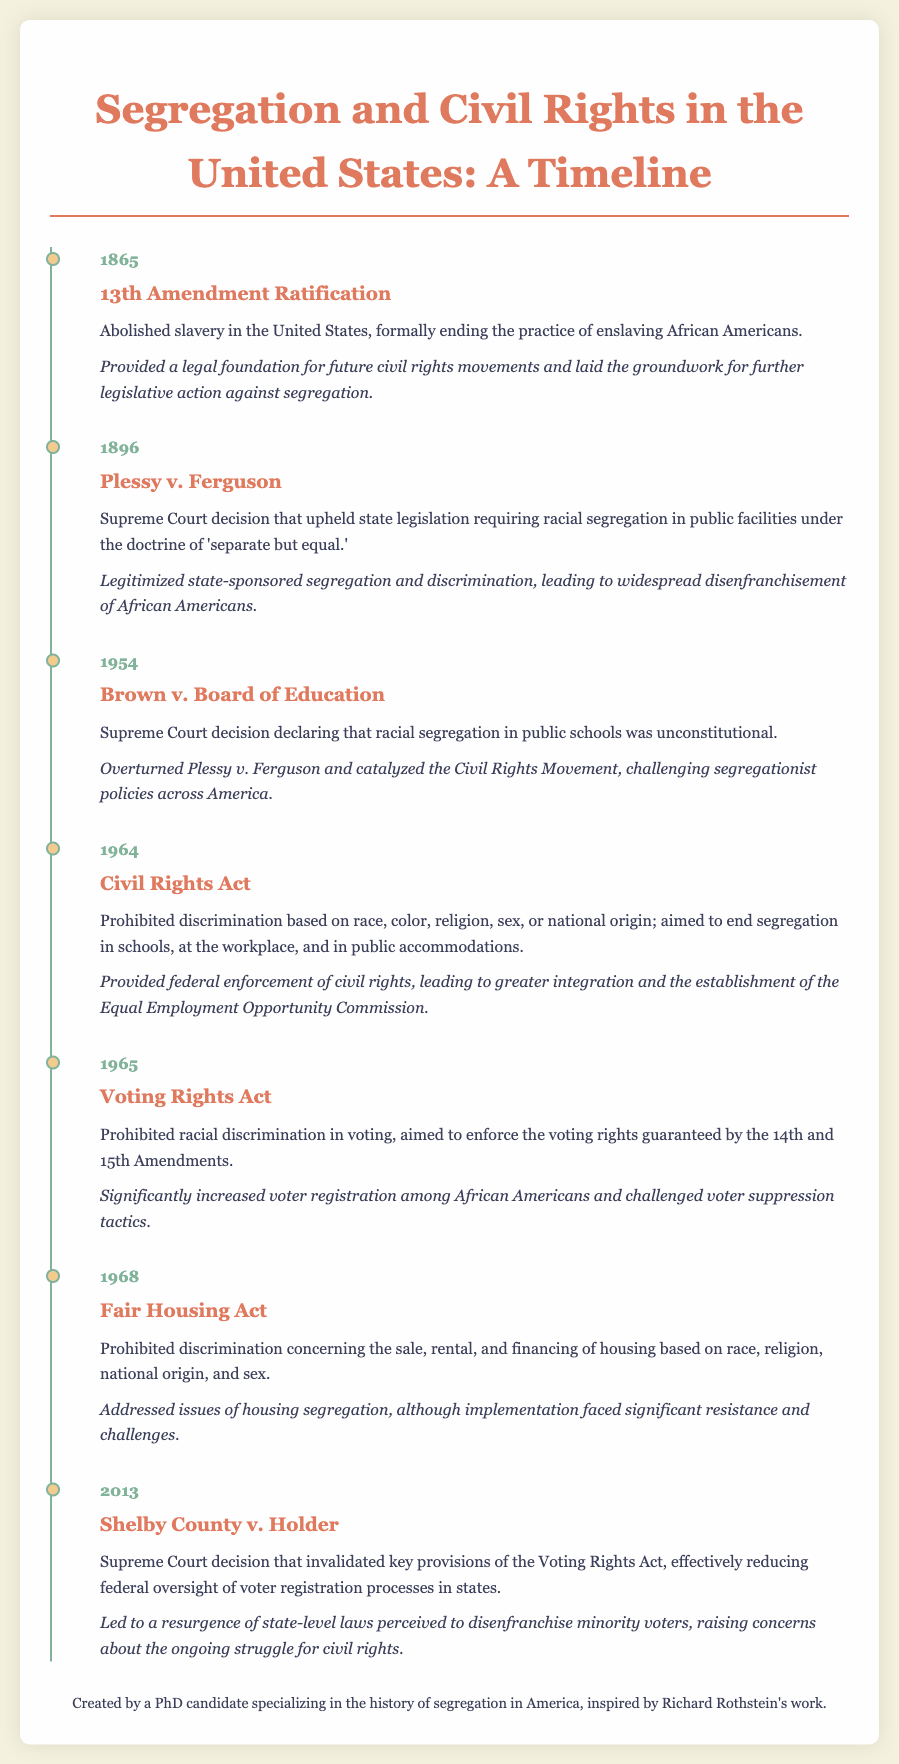What year was the 13th Amendment ratified? The 13th Amendment was ratified in 1865, as noted at the beginning of the timeline.
Answer: 1865 What Supreme Court case upheld the doctrine of 'separate but equal'? The case that upheld this doctrine is Plessy v. Ferguson, mentioned in the timeline.
Answer: Plessy v. Ferguson What major civil rights legislation was passed in 1964? The Civil Rights Act was passed in 1964, as indicated in the document.
Answer: Civil Rights Act What was the effect of the Voting Rights Act of 1965 on African American voter registration? The Voting Rights Act significantly increased voter registration among African Americans, according to the effects listed.
Answer: Increased voter registration Which act prohibited discrimination in housing? The Fair Housing Act, mentioned in the timeline, prohibits such discrimination.
Answer: Fair Housing Act How did the Shelby County v. Holder decision affect voter registration processes? It invalidated key provisions of the Voting Rights Act, reducing federal oversight of voter registration.
Answer: Reduced federal oversight Which event overturned Plessy v. Ferguson? The event that overturned this decision is Brown v. Board of Education noted in the timeline.
Answer: Brown v. Board of Education What was the main goal of the Civil Rights Act? The main goal was to prohibit discrimination based on race, color, religion, sex, or national origin.
Answer: Prohibit discrimination What legal change occurred in 2013 regarding the Voting Rights Act? The Supreme Court invalidated key provisions of the Voting Rights Act in 2013.
Answer: Invalidated key provisions 